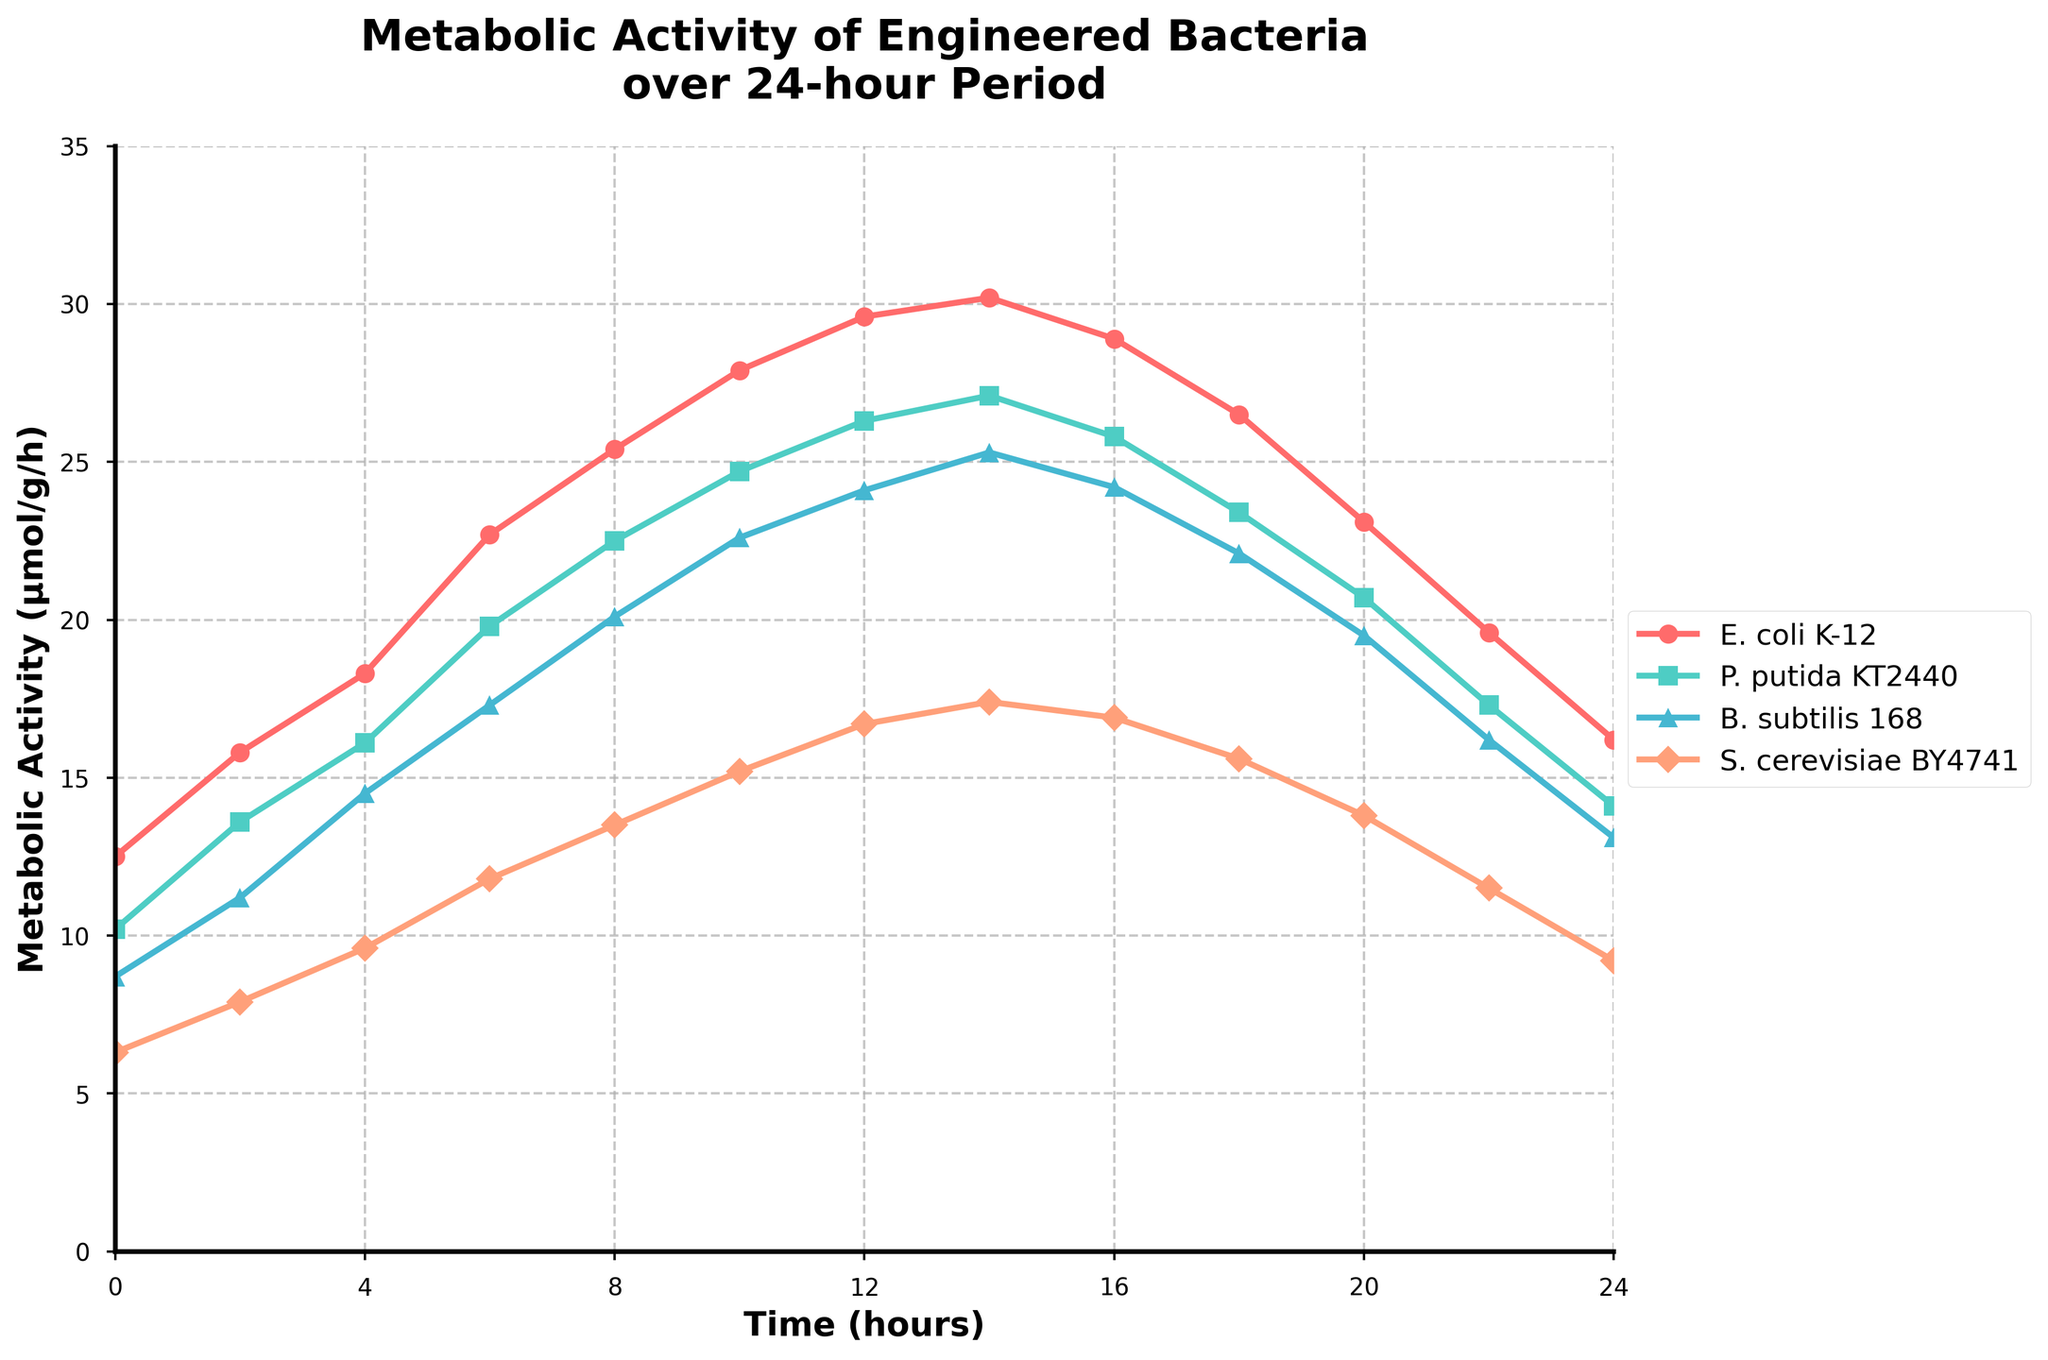Which organism has the highest metabolic activity at the 10-hour mark? Observe the data points for each organism at the 10-hour mark. The metabolic activities are: E. coli K-12 = 27.9, P. putida KT2440 = 24.7, B. subtilis 168 = 22.6, and S. cerevisiae BY4741 = 15.2. Compare these values to identify the highest one.
Answer: E. coli K-12 How does the metabolic activity of E. coli K-12 change from 0 hours to 24 hours? Observe the metabolic activity of E. coli K-12 at 0 hours and at 24 hours. The values are 12.5 and 16.2, respectively. The change is calculated by subtracting the initial value from the final value: 16.2 - 12.5.
Answer: It increases by 3.7 μmol/g/h Which organism shows a decrease in metabolic activity after the 14-hour mark? Look at the metabolic activities of all organisms at the 14-hour mark and compare them with the activity at the 16-hour mark. Identify any organisms whose activity decreases. Both E. coli K-12 and P. putida KT2440 show a decrease, but B. subtilis 168 and S. cerevisiae BY4741 continue to decrease as well.
Answer: All (B. subtilis 168, E. coli K-12, P. putida KT2440, S. cerevisiae BY4741) What is the peak metabolic activity of the P. putida KT2440 and at which hour is it observed? Review the metabolic activity values of P. putida KT2440 over the time period and identify the highest value and its corresponding hour.
Answer: 27.1 μmol/g/h at 14 hours Compare the metabolic activity between E. coli K-12 and B. subtilis 168 at the 6-hour mark. Which organism has a higher activity and by how much? Observe the metabolic activities of E. coli K-12 and B. subtilis 168 at the 6-hour mark. E. coli K-12 has 22.7, and B. subtilis 168 has 17.3. Subtract the value of B. subtilis 168 from E. coli K-12.
Answer: E. coli K-12 by 5.4 μmol/g/h What is the average metabolic activity of S. cerevisiae BY4741 over the 24-hour period? Sum the metabolic activities of S. cerevisiae BY4741 at all provided time points and divide by the number of time points. The sum is 6.3+7.9+9.6+11.8+13.5+15.2+16.7+17.4+16.9+15.6+13.8+11.5+9.2 = 155.4. There are 13 time points. Divide 155.4 by 13.
Answer: 11.95 μmol/g/h What is the ratio of the metabolic activity of B. subtilis 168 to P. putida KT2440 at the 20-hour mark? Observe the metabolic activities of both B. subtilis 168 and P. putida KT2440 at the 20-hour mark. The values are 19.5 for B. subtilis 168 and 20.7 for P. putida KT2440. Divide the value of B. subtilis 168 by P. putida KT2440.
Answer: Approximately 0.94 Between which hours does E. coli K-12 show the steepest increase in metabolic activity? Calculate the difference in metabolic activity between consecutive time points for E. coli K-12. The steepest increase is the highest positive difference. For example, from 0 to 2 hours it's 15.8 - 12.5 = 3.3, from 2 to 4 hours it's 18.3 - 15.8 = 2.5, etc. The steepest increase occurs from 6 to 8 hours where the difference is 25.4 - 22.7 = 2.7.
Answer: Between 6 and 8 hours What is the total metabolic activity observed for B. subtilis 168 over the entire 24-hour period? Sum the metabolic activities of B. subtilis 168 at all provided time points. 8.7+11.2+14.5+17.3+20.1+22.6+24.1+25.3+24.2+22.1+19.5+16.2+13.1 = 218.9.
Answer: 218.9 μmol/g/h 